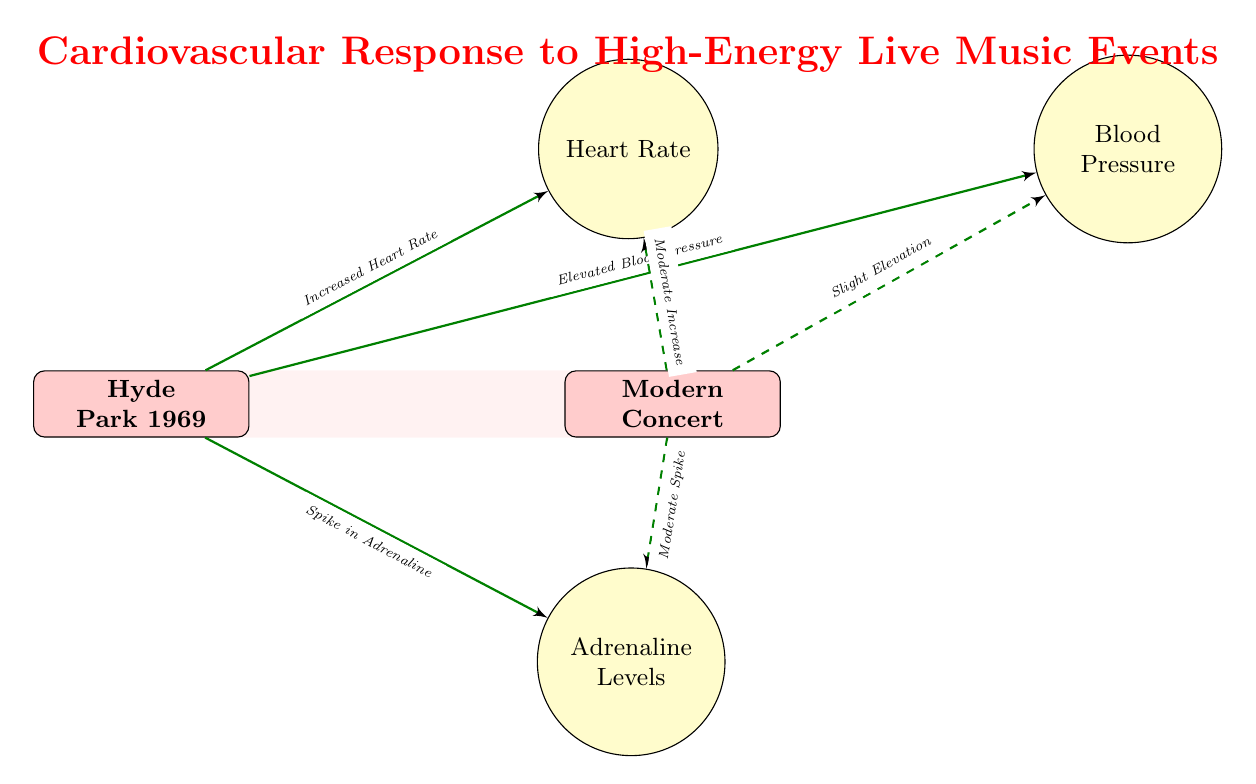What event is represented in the diagram? The diagram explicitly identifies the event being studied at the top left node as "Hyde Park 1969". Thus, this is the event to answer the question.
Answer: Hyde Park 1969 What is the main cardiovascular response indicated for the Hyde Park show? The diagram features three distinct responses connected to the Hyde Park node: "Increased Heart Rate," "Elevated Blood Pressure," and "Spike in Adrenaline." These responses characterize the main cardiovascular reactions to the concert.
Answer: Increased Heart Rate, Elevated Blood Pressure, Spike in Adrenaline What type of response does the modern concert show for heart rate? The diagram shows a "Moderate Increase" in heart rate connected with a dashed line from the modern concert node to the heart rate response node. This differentiated response style indicates a lesser effect compared to the Hyde Park show.
Answer: Moderate Increase How many cardiovascular responses are associated with the Hyde Park show? Examining the diagram reveals three cardiovascular responses connected to the Hyde Park node: heart rate, blood pressure, and adrenaline levels. Hence, the count of responses is three.
Answer: 3 What do the dashed edges represent in the diagram? The dashed edges in the diagram connecting the modern concert to its responses imply a less significant or moderate impact compared to the solid arrows from the Hyde Park show, which indicates a more significant physiological response. Thus, dashed edges reflect a lower intensity of change.
Answer: Moderate impact Which cardiovascular response is associated with a spike in adrenaline levels? The diagram links "Spike in Adrenaline" directly to the Hyde Park show using an increasing (solid) edge. This clearly denotes that the adrenaline surge corresponds to the high-energy without ambiguity.
Answer: Spike in Adrenaline Which cardiovascular response shows a slight elevation in the modern concert? The diagram specifies that the modern concert node leads to a "Slight Elevation" in blood pressure, establishing a conclusive connection between the concert and this particular response.
Answer: Slight Elevation What does the color code of the nodes indicate in this diagram? The diagram utilizes different colors for the types of nodes with event nodes in red and response nodes in yellow. This color coding distinguishes between the events being studied and the physiological responses akin to them, facilitating understanding.
Answer: Events are red, responses are yellow 